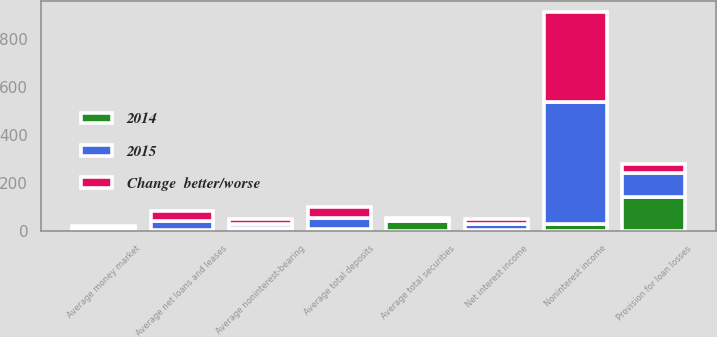<chart> <loc_0><loc_0><loc_500><loc_500><stacked_bar_chart><ecel><fcel>Average net loans and leases<fcel>Average money market<fcel>Average total securities<fcel>Average noninterest-bearing<fcel>Average total deposits<fcel>Net interest income<fcel>Provision for loan losses<fcel>Noninterest income<nl><fcel>Change  better/worse<fcel>40.2<fcel>8.3<fcel>5.8<fcel>21.4<fcel>48.6<fcel>23.7<fcel>40<fcel>377.1<nl><fcel>2015<fcel>39.5<fcel>8.2<fcel>4.1<fcel>19.6<fcel>46.3<fcel>23.7<fcel>98.1<fcel>508.6<nl><fcel>2014<fcel>2<fcel>1<fcel>41<fcel>9<fcel>5<fcel>2<fcel>141<fcel>26<nl></chart> 